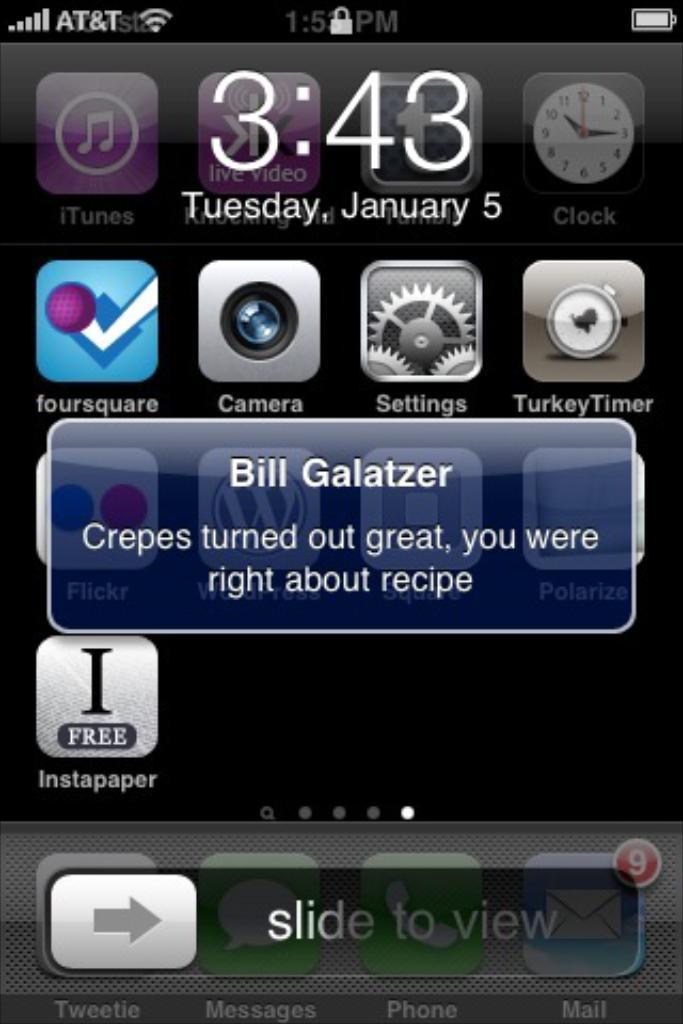Who is texting in this image?
Your response must be concise. Bill galatzer. What time does it say?
Give a very brief answer. 3:43. 